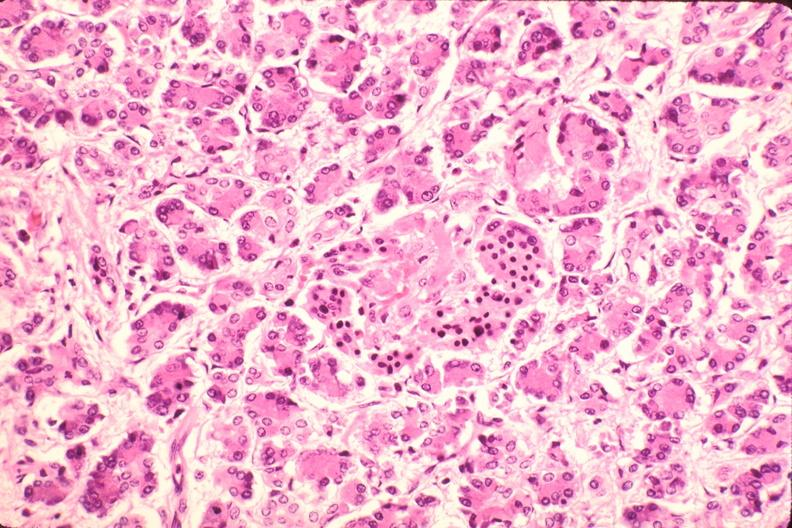s endocrine present?
Answer the question using a single word or phrase. Yes 